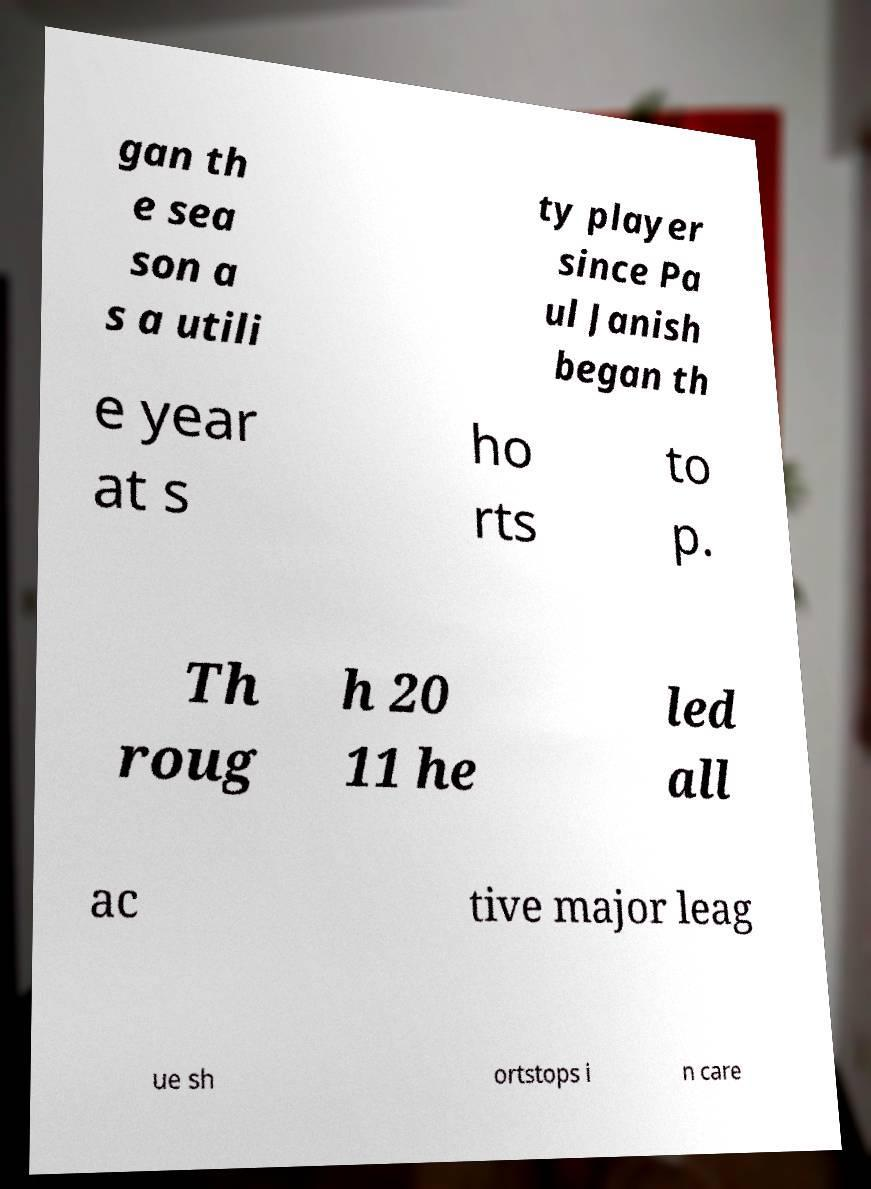Could you extract and type out the text from this image? gan th e sea son a s a utili ty player since Pa ul Janish began th e year at s ho rts to p. Th roug h 20 11 he led all ac tive major leag ue sh ortstops i n care 